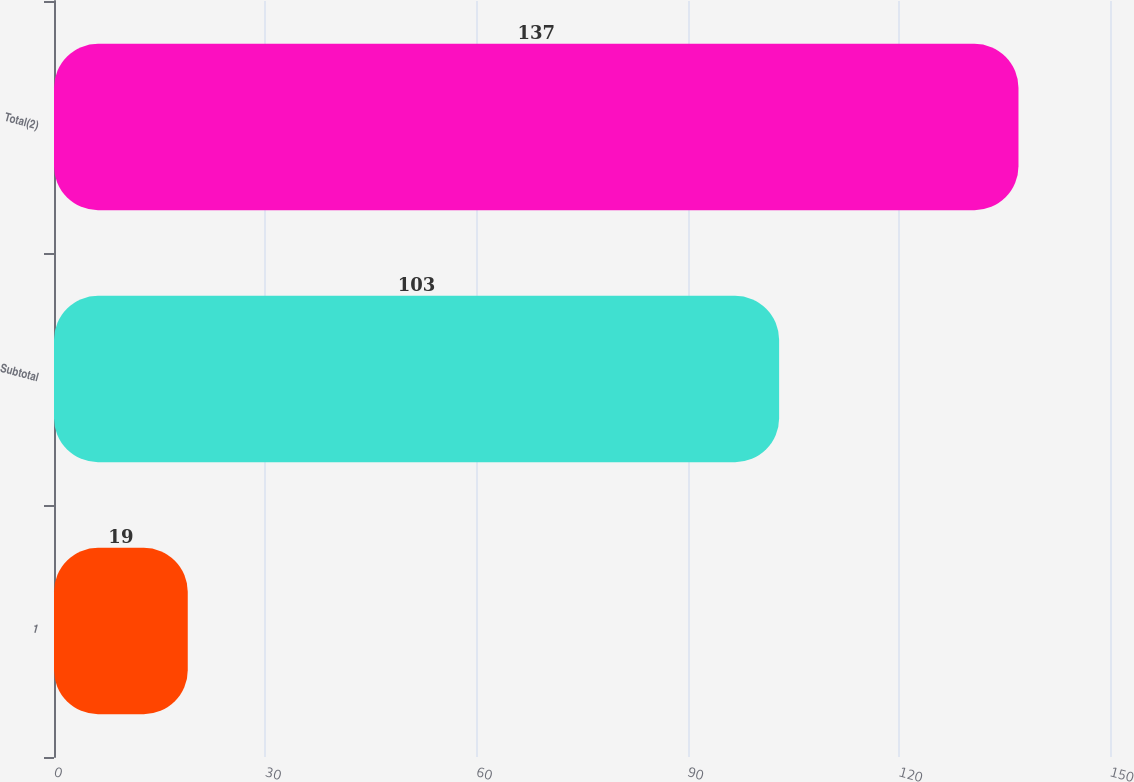<chart> <loc_0><loc_0><loc_500><loc_500><bar_chart><fcel>1<fcel>Subtotal<fcel>Total(2)<nl><fcel>19<fcel>103<fcel>137<nl></chart> 